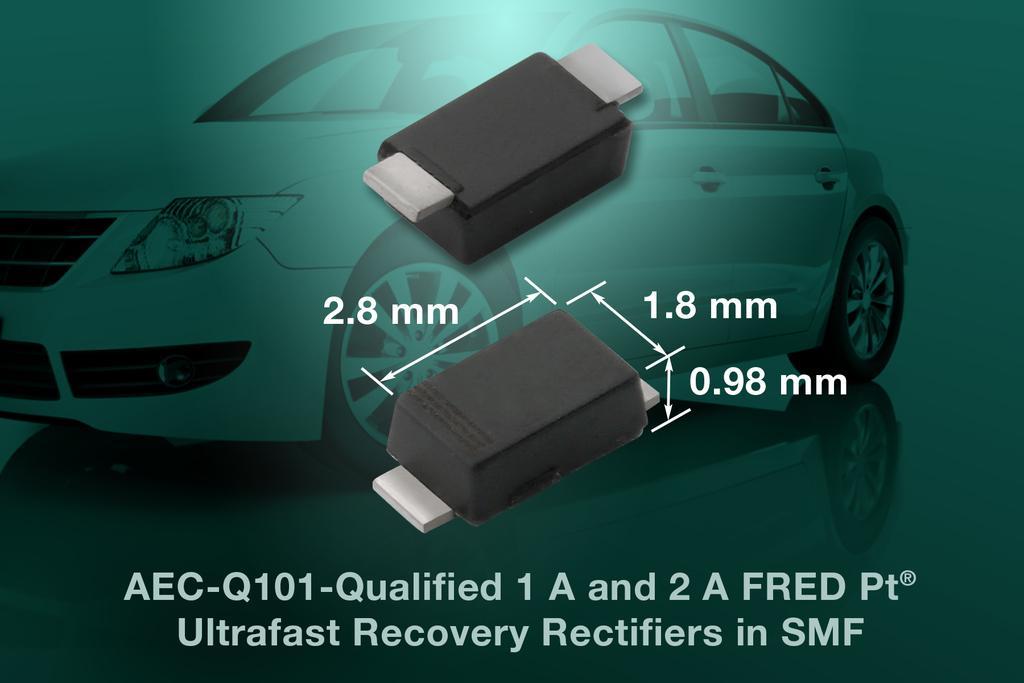In one or two sentences, can you explain what this image depicts? In this image we can see the poster. And there are pen drives and car and there is the text written on the poster. 